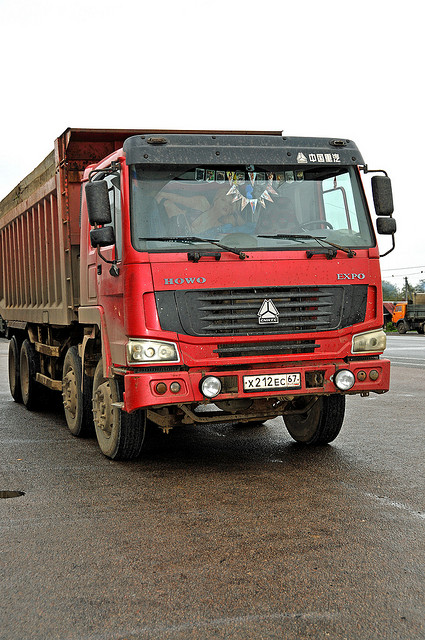Read and extract the text from this image. HOWO EXPO X2 12 EC 67 